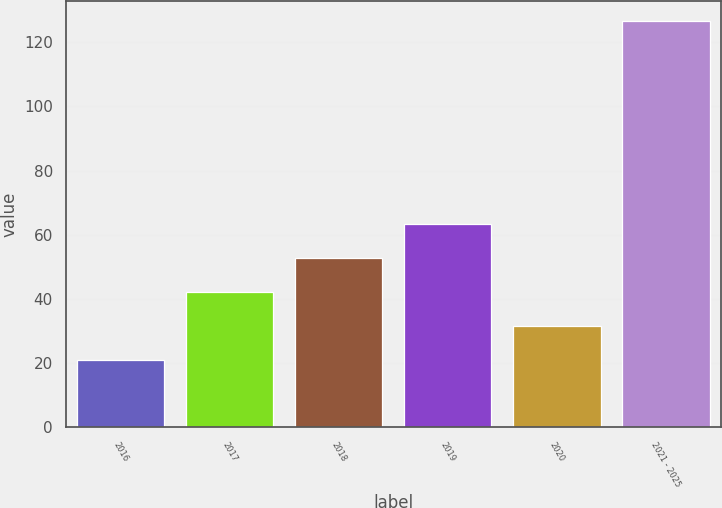Convert chart. <chart><loc_0><loc_0><loc_500><loc_500><bar_chart><fcel>2016<fcel>2017<fcel>2018<fcel>2019<fcel>2020<fcel>2021 - 2025<nl><fcel>21.1<fcel>42.18<fcel>52.72<fcel>63.26<fcel>31.64<fcel>126.5<nl></chart> 